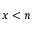Convert formula to latex. <formula><loc_0><loc_0><loc_500><loc_500>x < n</formula> 